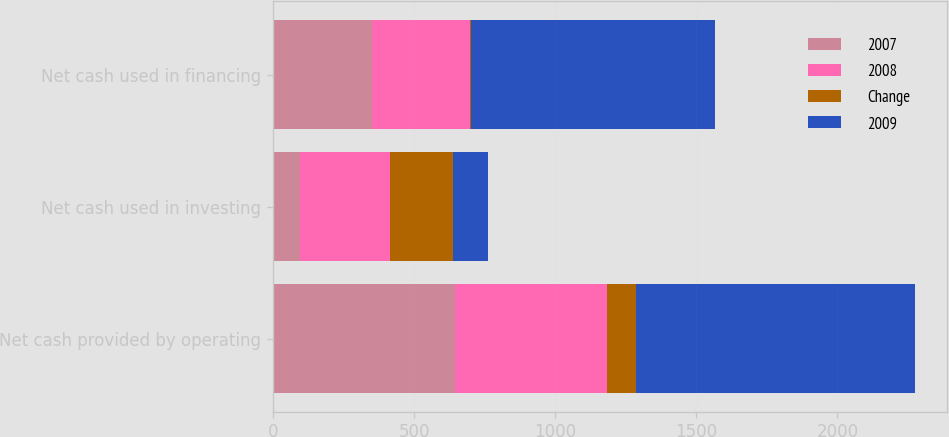Convert chart. <chart><loc_0><loc_0><loc_500><loc_500><stacked_bar_chart><ecel><fcel>Net cash provided by operating<fcel>Net cash used in investing<fcel>Net cash used in financing<nl><fcel>2007<fcel>643.8<fcel>93.8<fcel>348.8<nl><fcel>2008<fcel>539.7<fcel>319.3<fcel>349.8<nl><fcel>Change<fcel>104.1<fcel>225.5<fcel>1<nl><fcel>2009<fcel>988.2<fcel>124.7<fcel>865.7<nl></chart> 